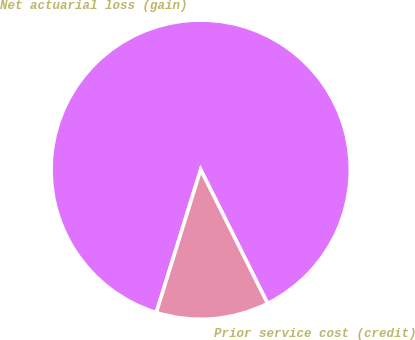<chart> <loc_0><loc_0><loc_500><loc_500><pie_chart><fcel>Net actuarial loss (gain)<fcel>Prior service cost (credit)<nl><fcel>87.83%<fcel>12.17%<nl></chart> 